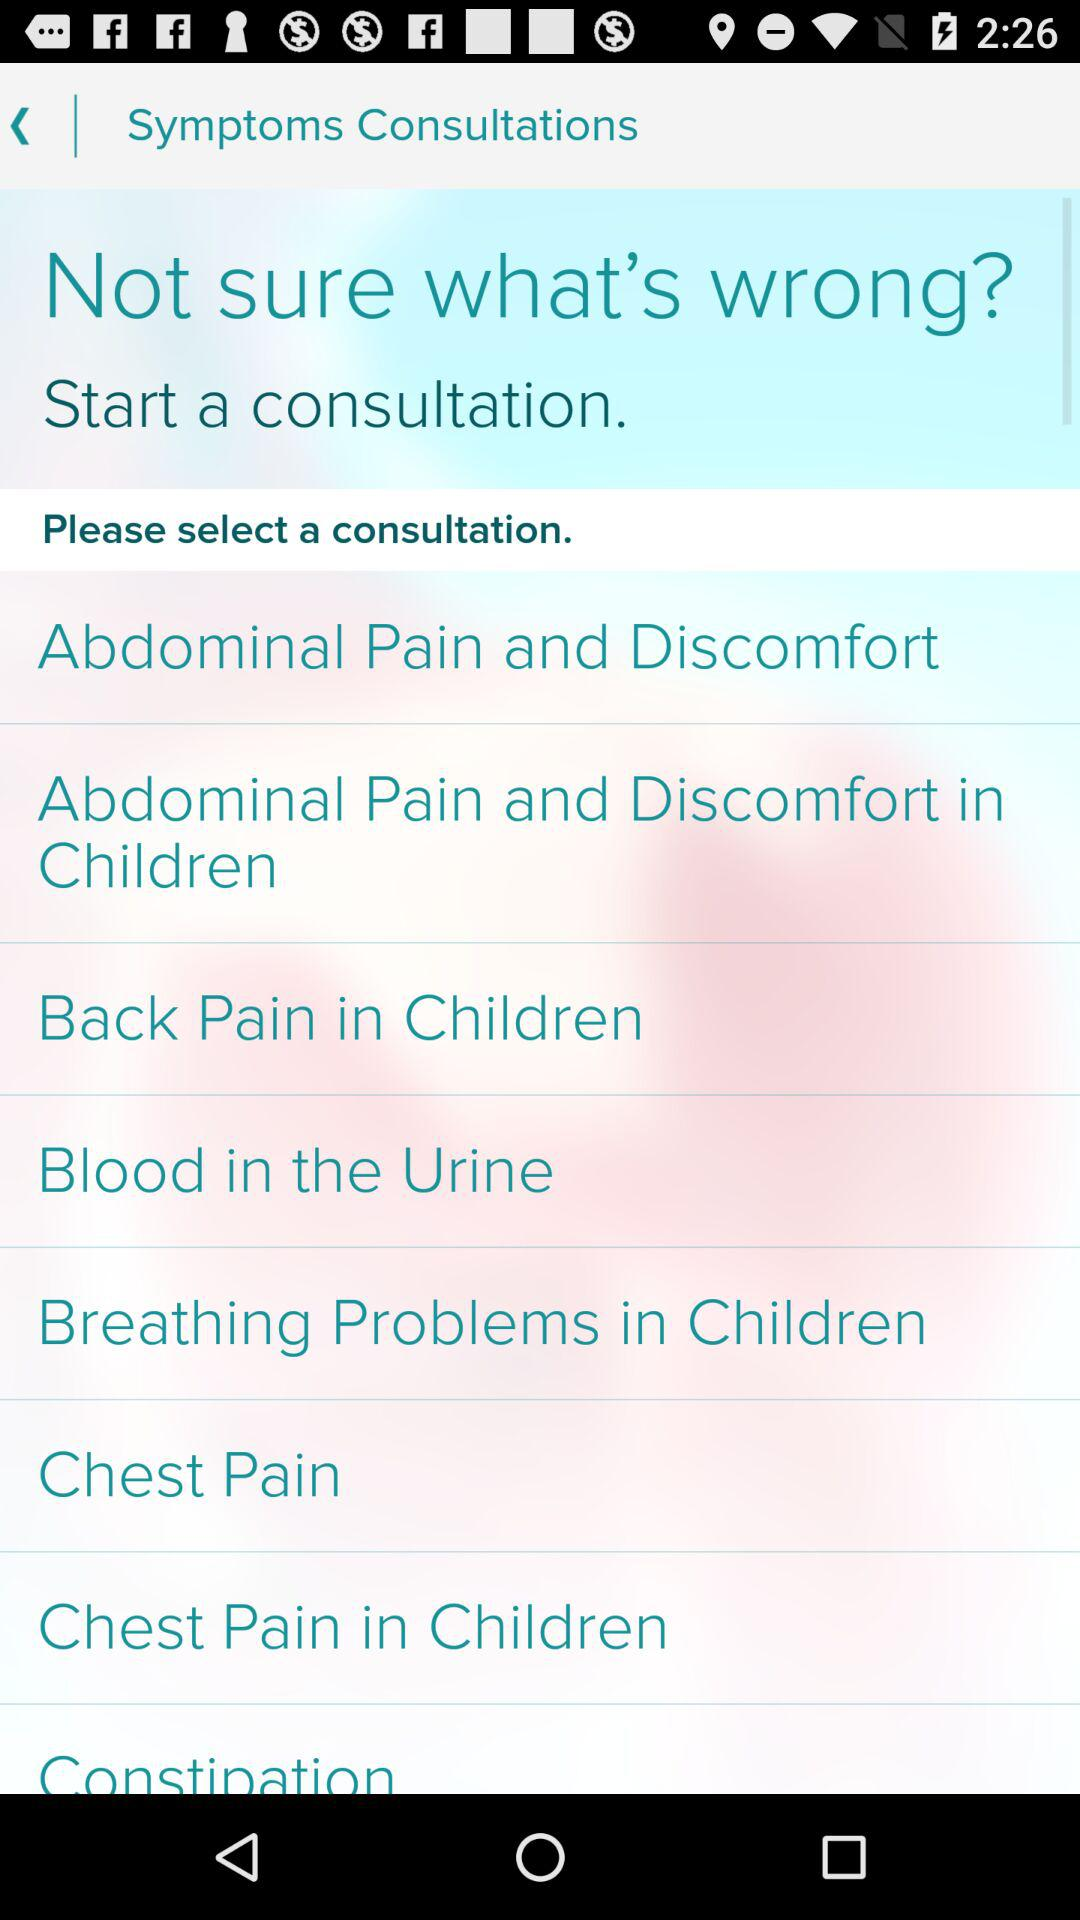How many consultations are there in total?
Answer the question using a single word or phrase. 8 